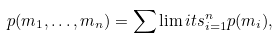<formula> <loc_0><loc_0><loc_500><loc_500>p ( m _ { 1 } , \dots , m _ { n } ) = \sum \lim i t s _ { i = 1 } ^ { n } p ( m _ { i } ) ,</formula> 